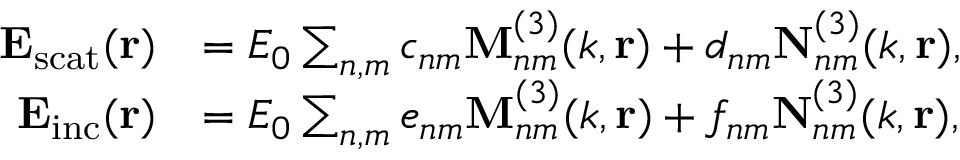<formula> <loc_0><loc_0><loc_500><loc_500>\begin{array} { r l } { E _ { s c a t } ( r ) } & { = E _ { 0 } \sum _ { n , m } c _ { n m } M _ { n m } ^ { ( 3 ) } ( k , r ) + d _ { n m } N _ { n m } ^ { ( 3 ) } ( k , r ) , } \\ { E _ { i n c } ( r ) } & { = E _ { 0 } \sum _ { n , m } e _ { n m } M _ { n m } ^ { ( 3 ) } ( k , r ) + f _ { n m } N _ { n m } ^ { ( 3 ) } ( k , r ) , } \end{array}</formula> 